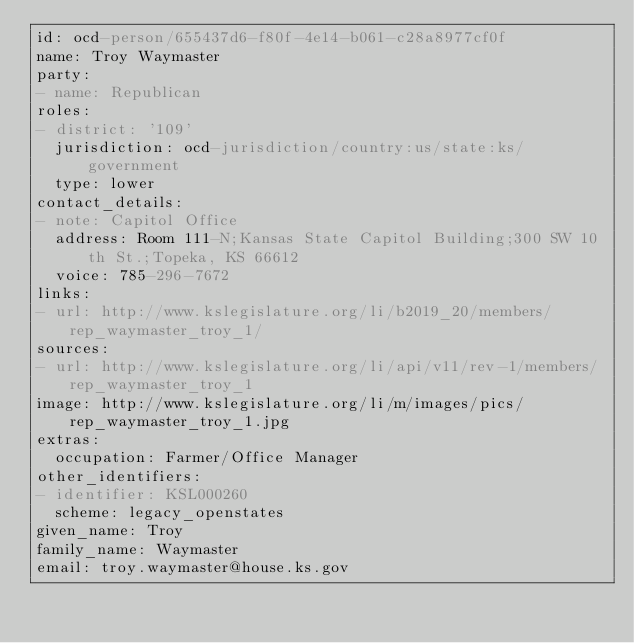<code> <loc_0><loc_0><loc_500><loc_500><_YAML_>id: ocd-person/655437d6-f80f-4e14-b061-c28a8977cf0f
name: Troy Waymaster
party:
- name: Republican
roles:
- district: '109'
  jurisdiction: ocd-jurisdiction/country:us/state:ks/government
  type: lower
contact_details:
- note: Capitol Office
  address: Room 111-N;Kansas State Capitol Building;300 SW 10th St.;Topeka, KS 66612
  voice: 785-296-7672
links:
- url: http://www.kslegislature.org/li/b2019_20/members/rep_waymaster_troy_1/
sources:
- url: http://www.kslegislature.org/li/api/v11/rev-1/members/rep_waymaster_troy_1
image: http://www.kslegislature.org/li/m/images/pics/rep_waymaster_troy_1.jpg
extras:
  occupation: Farmer/Office Manager
other_identifiers:
- identifier: KSL000260
  scheme: legacy_openstates
given_name: Troy
family_name: Waymaster
email: troy.waymaster@house.ks.gov
</code> 